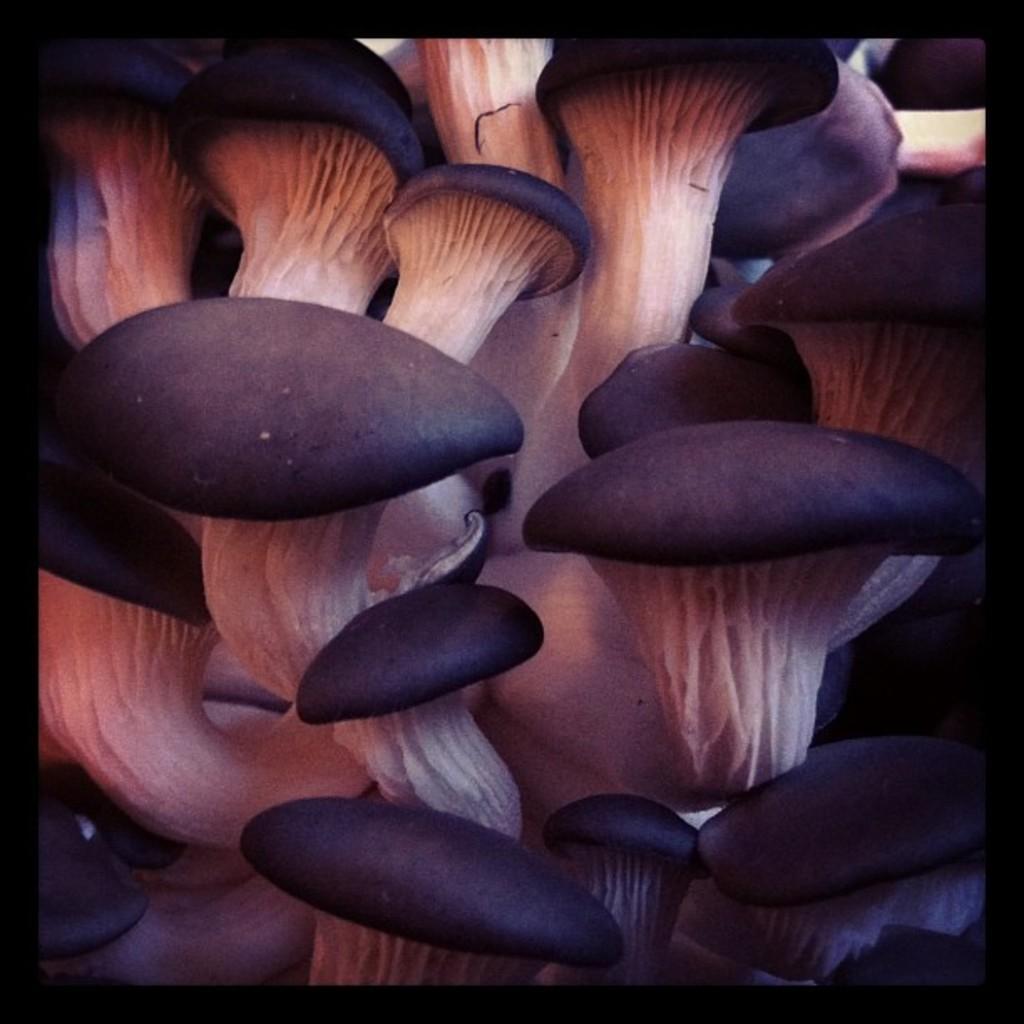Can you describe this image briefly? In this image I can see number of black and white colour mushrooms. 